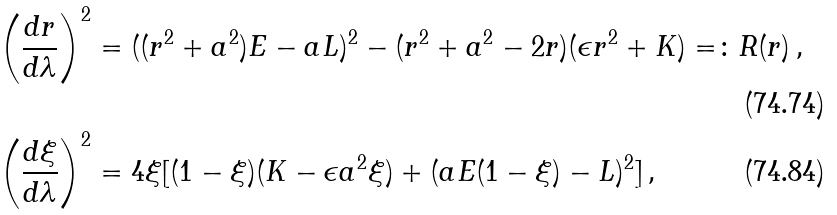Convert formula to latex. <formula><loc_0><loc_0><loc_500><loc_500>\left ( \frac { d r } { d \lambda } \right ) ^ { 2 } & = ( ( r ^ { 2 } + a ^ { 2 } ) E - a L ) ^ { 2 } - ( r ^ { 2 } + a ^ { 2 } - 2 r ) ( \epsilon r ^ { 2 } + K ) = \colon R ( r ) \, , \\ \left ( \frac { d \xi } { d \lambda } \right ) ^ { 2 } & = 4 \xi [ ( 1 - \xi ) ( K - \epsilon a ^ { 2 } \xi ) + ( a E ( 1 - \xi ) - L ) ^ { 2 } ] \, ,</formula> 